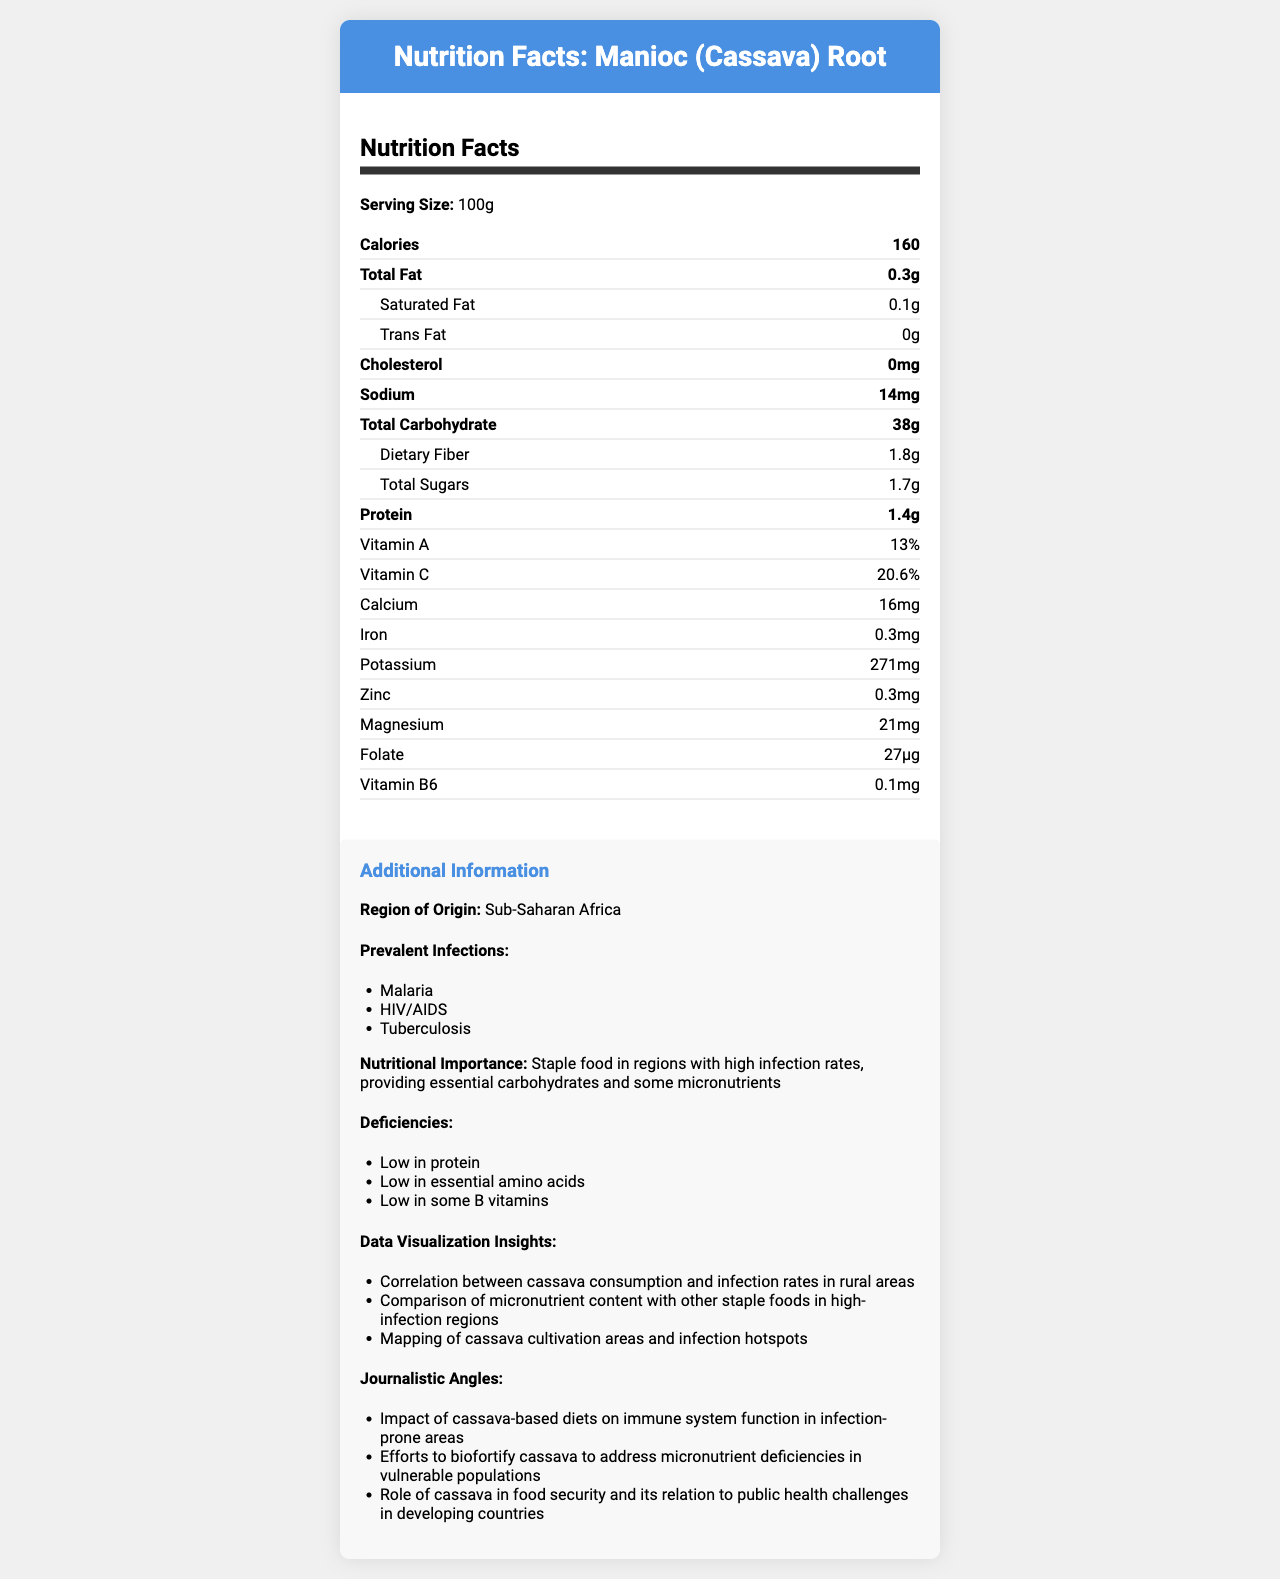what is the serving size of Manioc (Cassava) Root? The serving size is explicitly stated at the beginning of the nutrition facts in the document.
Answer: 100g how many calories are there per serving? The document specifies that there are 160 calories per 100g serving of Manioc (Cassava) Root.
Answer: 160 how much protein is in a 100g serving? The nutrition facts indicate that there are 1.4g of protein per serving.
Answer: 1.4g which vitamin is present in higher quantity, vitamin A or vitamin C? The document shows that Vitamin A is 13% whereas Vitamin C is 20.6%.
Answer: Vitamin C what is the iron content in milligrams? The nutrition label shows iron content as 0.3mg per serving.
Answer: 0.3mg how much total fat does a 100g serving contain? The nutrition facts state that total fat is 0.3g per 100g serving.
Answer: 0.3g how much sodium is in a 100g serving? The sodium content is listed as 14mg per serving.
Answer: 14mg is Manioc (Cassava) Root high in protein? The document states that it is low in protein and shows only 1.4g per serving.
Answer: No what region is the Manioc (Cassava) Root commonly grown? The additional information section specifies the region of origin as Sub-Saharan Africa.
Answer: Sub-Saharan Africa how much dietary fiber is in each serving? The document lists 1.8g of dietary fiber per 100g serving.
Answer: 1.8g what is the nutritional importance of Manioc (Cassava) Root? The nutritional importance section describes its role.
Answer: Staple food in regions with high infection rates, providing essential carbohydrates and some micronutrients what are the prevalent infections in the regions where Manioc (Cassava) Root is grown? The additional information section lists these infections as prevalent in Sub-Saharan Africa.
Answer: Malaria, HIV/AIDS, Tuberculosis how much potassium is in 100g of Manioc (Cassava) Root? The nutritional facts indicate a potassium content of 271mg.
Answer: 271mg which of the following is a micronutrient deficiency in Manioc (Cassava) Root? A. Vitamin D B. Protein C. Vitamin B12 D. Thiamine The document lists "Low in protein" as a deficiency.
Answer: B. Protein which data visualization insight is mentioned? I. Correlation between cassava consumption and infection rates II. Impact of cassava on obesity rates III. Comparison with fruits The document lists "Correlation between cassava consumption and infection rates" and "Comparison of micronutrient content with other staple foods" as insights.
Answer: I, III does Manioc (Cassava) Root contain cholesterol? The nutrient facts explicitly state that cholesterol content is 0mg.
Answer: No summarize the main points of this document. The document includes detailed nutritional information, additional context on the importance and deficiencies of Manioc, and offers insights and angles for journalistic exploration.
Answer: The document provides a detailed nutrition facts label for Manioc (Cassava) Root, showing its contents per 100g serving. It emphasizes the importance of Manioc as a staple food in Sub-Saharan Africa, especially in regions with infections like Malaria, HIV/AIDS, and Tuberculosis. It also highlights nutritional deficiencies and presents insights and journalistic opportunities related to cassava consumption and public health. how much trans fat is in Manioc (Cassava) Root? The document shows that trans fat content is 0g.
Answer: 0g are efforts being made to biofortify cassava? The document mentions efforts to biofortify cassava to address micronutrient deficiencies.
Answer: Yes where was the cassava harvested? The document does not provide specifics about the exact locations of harvest.
Answer: Not enough information 